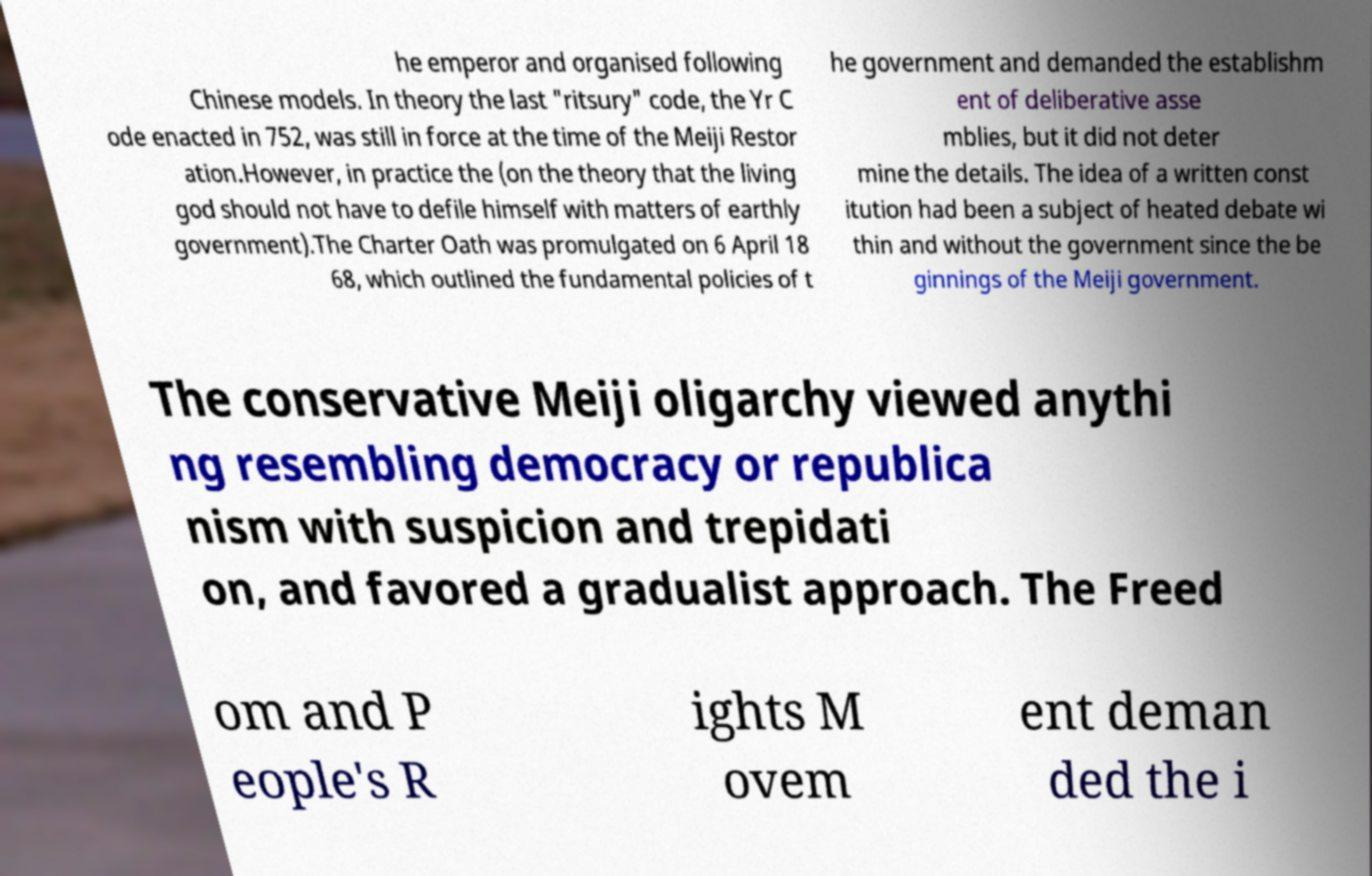Could you extract and type out the text from this image? he emperor and organised following Chinese models. In theory the last "ritsury" code, the Yr C ode enacted in 752, was still in force at the time of the Meiji Restor ation.However, in practice the (on the theory that the living god should not have to defile himself with matters of earthly government).The Charter Oath was promulgated on 6 April 18 68, which outlined the fundamental policies of t he government and demanded the establishm ent of deliberative asse mblies, but it did not deter mine the details. The idea of a written const itution had been a subject of heated debate wi thin and without the government since the be ginnings of the Meiji government. The conservative Meiji oligarchy viewed anythi ng resembling democracy or republica nism with suspicion and trepidati on, and favored a gradualist approach. The Freed om and P eople's R ights M ovem ent deman ded the i 